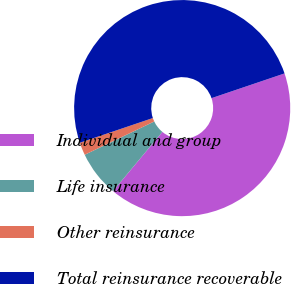<chart> <loc_0><loc_0><loc_500><loc_500><pie_chart><fcel>Individual and group<fcel>Life insurance<fcel>Other reinsurance<fcel>Total reinsurance recoverable<nl><fcel>41.25%<fcel>6.84%<fcel>1.91%<fcel>50.0%<nl></chart> 